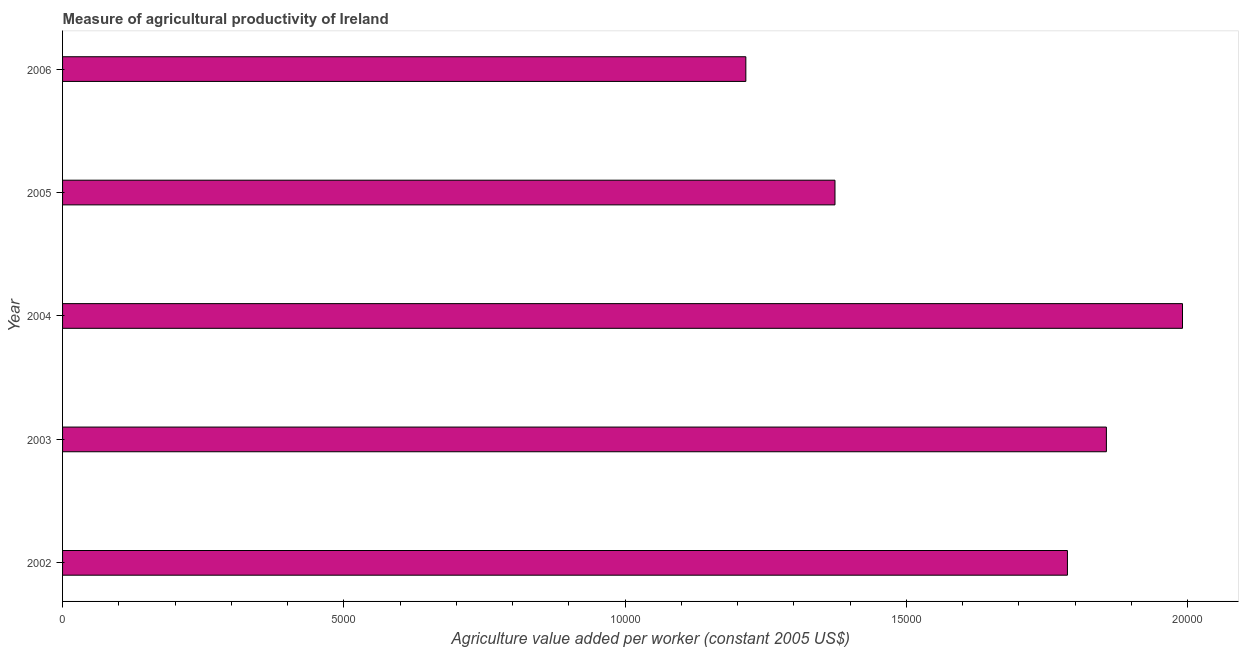Does the graph contain any zero values?
Give a very brief answer. No. What is the title of the graph?
Make the answer very short. Measure of agricultural productivity of Ireland. What is the label or title of the X-axis?
Provide a succinct answer. Agriculture value added per worker (constant 2005 US$). What is the label or title of the Y-axis?
Your answer should be compact. Year. What is the agriculture value added per worker in 2003?
Your response must be concise. 1.86e+04. Across all years, what is the maximum agriculture value added per worker?
Offer a very short reply. 1.99e+04. Across all years, what is the minimum agriculture value added per worker?
Make the answer very short. 1.21e+04. In which year was the agriculture value added per worker maximum?
Keep it short and to the point. 2004. What is the sum of the agriculture value added per worker?
Keep it short and to the point. 8.22e+04. What is the difference between the agriculture value added per worker in 2003 and 2005?
Provide a succinct answer. 4824.51. What is the average agriculture value added per worker per year?
Your answer should be very brief. 1.64e+04. What is the median agriculture value added per worker?
Provide a succinct answer. 1.79e+04. In how many years, is the agriculture value added per worker greater than 13000 US$?
Keep it short and to the point. 4. What is the ratio of the agriculture value added per worker in 2004 to that in 2006?
Your answer should be compact. 1.64. What is the difference between the highest and the second highest agriculture value added per worker?
Keep it short and to the point. 1352.92. What is the difference between the highest and the lowest agriculture value added per worker?
Provide a succinct answer. 7761.82. What is the difference between two consecutive major ticks on the X-axis?
Ensure brevity in your answer.  5000. What is the Agriculture value added per worker (constant 2005 US$) in 2002?
Your answer should be very brief. 1.79e+04. What is the Agriculture value added per worker (constant 2005 US$) of 2003?
Your answer should be very brief. 1.86e+04. What is the Agriculture value added per worker (constant 2005 US$) of 2004?
Provide a short and direct response. 1.99e+04. What is the Agriculture value added per worker (constant 2005 US$) of 2005?
Make the answer very short. 1.37e+04. What is the Agriculture value added per worker (constant 2005 US$) of 2006?
Keep it short and to the point. 1.21e+04. What is the difference between the Agriculture value added per worker (constant 2005 US$) in 2002 and 2003?
Your answer should be very brief. -692.45. What is the difference between the Agriculture value added per worker (constant 2005 US$) in 2002 and 2004?
Your answer should be very brief. -2045.38. What is the difference between the Agriculture value added per worker (constant 2005 US$) in 2002 and 2005?
Ensure brevity in your answer.  4132.05. What is the difference between the Agriculture value added per worker (constant 2005 US$) in 2002 and 2006?
Ensure brevity in your answer.  5716.44. What is the difference between the Agriculture value added per worker (constant 2005 US$) in 2003 and 2004?
Your response must be concise. -1352.92. What is the difference between the Agriculture value added per worker (constant 2005 US$) in 2003 and 2005?
Give a very brief answer. 4824.5. What is the difference between the Agriculture value added per worker (constant 2005 US$) in 2003 and 2006?
Ensure brevity in your answer.  6408.9. What is the difference between the Agriculture value added per worker (constant 2005 US$) in 2004 and 2005?
Offer a very short reply. 6177.43. What is the difference between the Agriculture value added per worker (constant 2005 US$) in 2004 and 2006?
Your answer should be very brief. 7761.82. What is the difference between the Agriculture value added per worker (constant 2005 US$) in 2005 and 2006?
Keep it short and to the point. 1584.39. What is the ratio of the Agriculture value added per worker (constant 2005 US$) in 2002 to that in 2003?
Offer a terse response. 0.96. What is the ratio of the Agriculture value added per worker (constant 2005 US$) in 2002 to that in 2004?
Your answer should be compact. 0.9. What is the ratio of the Agriculture value added per worker (constant 2005 US$) in 2002 to that in 2005?
Your response must be concise. 1.3. What is the ratio of the Agriculture value added per worker (constant 2005 US$) in 2002 to that in 2006?
Offer a very short reply. 1.47. What is the ratio of the Agriculture value added per worker (constant 2005 US$) in 2003 to that in 2004?
Provide a succinct answer. 0.93. What is the ratio of the Agriculture value added per worker (constant 2005 US$) in 2003 to that in 2005?
Offer a terse response. 1.35. What is the ratio of the Agriculture value added per worker (constant 2005 US$) in 2003 to that in 2006?
Offer a terse response. 1.53. What is the ratio of the Agriculture value added per worker (constant 2005 US$) in 2004 to that in 2005?
Your answer should be very brief. 1.45. What is the ratio of the Agriculture value added per worker (constant 2005 US$) in 2004 to that in 2006?
Offer a very short reply. 1.64. What is the ratio of the Agriculture value added per worker (constant 2005 US$) in 2005 to that in 2006?
Keep it short and to the point. 1.13. 